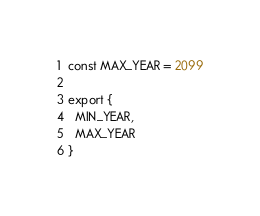Convert code to text. <code><loc_0><loc_0><loc_500><loc_500><_JavaScript_>const MAX_YEAR = 2099

export {
  MIN_YEAR,
  MAX_YEAR
}
</code> 